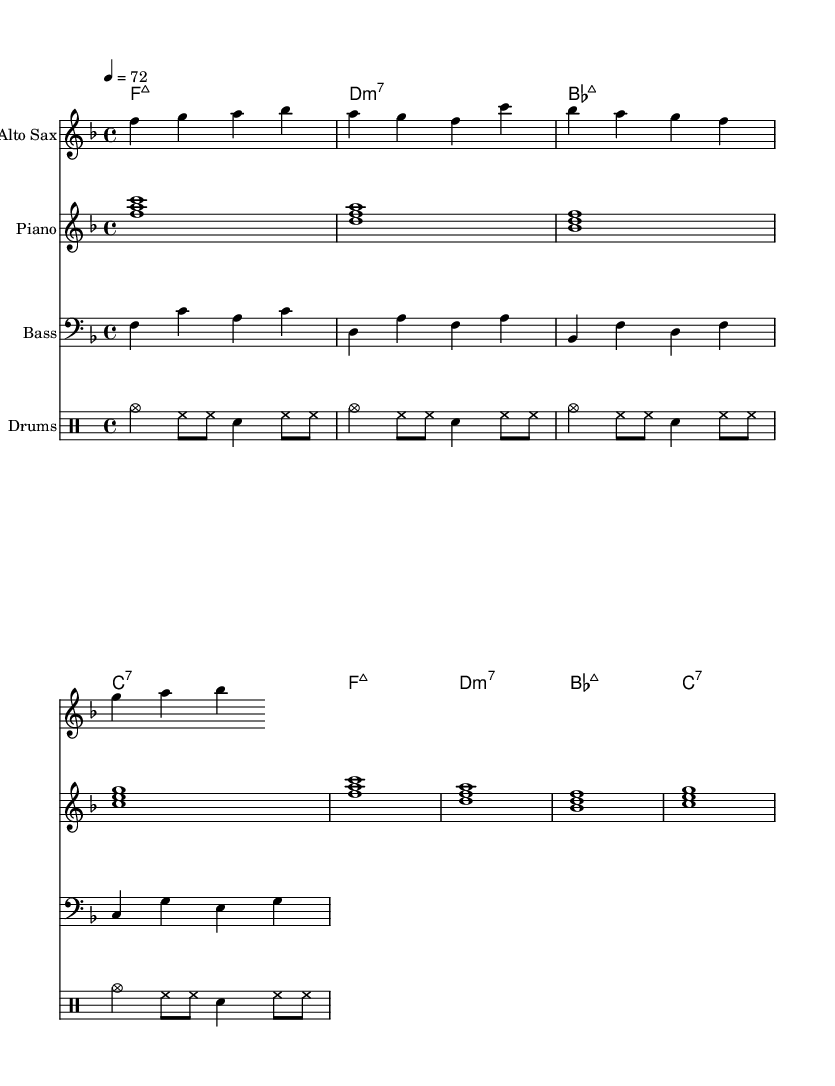What is the key signature of this music? The key signature is F major, which has one flat (B flat). This can be determined from the key signature notation found at the beginning of the staff.
Answer: F major What is the time signature of this music? The time signature is 4/4, which signifies that there are four beats per measure and the quarter note receives one beat. This is indicated at the start of the piece, following the key signature.
Answer: 4/4 What is the tempo marking of this music? The tempo marking is quarter note = 72, denoting that the piece should be played at a speed of 72 beats per minute. This information is found within the tempo indication at the start.
Answer: 72 How many measures are in the piece? There are 8 measures in total in the score shown. This can be counted by reviewing how the music is divided into bars, which are separated by vertical lines.
Answer: 8 Which instruments are featured in this score? The instruments featured include Alto Sax, Piano, Bass, and Drums. Each instrument is labeled at the beginning of its respective staff in the sheet music.
Answer: Alto Sax, Piano, Bass, Drums How many sharps or flats are in the key signature? There is one flat in the key signature. Since it is in F major, which has the flat note B flat, this is easily identified from the key signature at the beginning.
Answer: 1 flat What type of jazz is represented by this piece? The piece showcases Smooth Jazz, a genre characterized by its relaxed tempo and melodic instrumentation. This can be inferred from the arrangement's laid-back style and instrumentation choice.
Answer: Smooth Jazz 